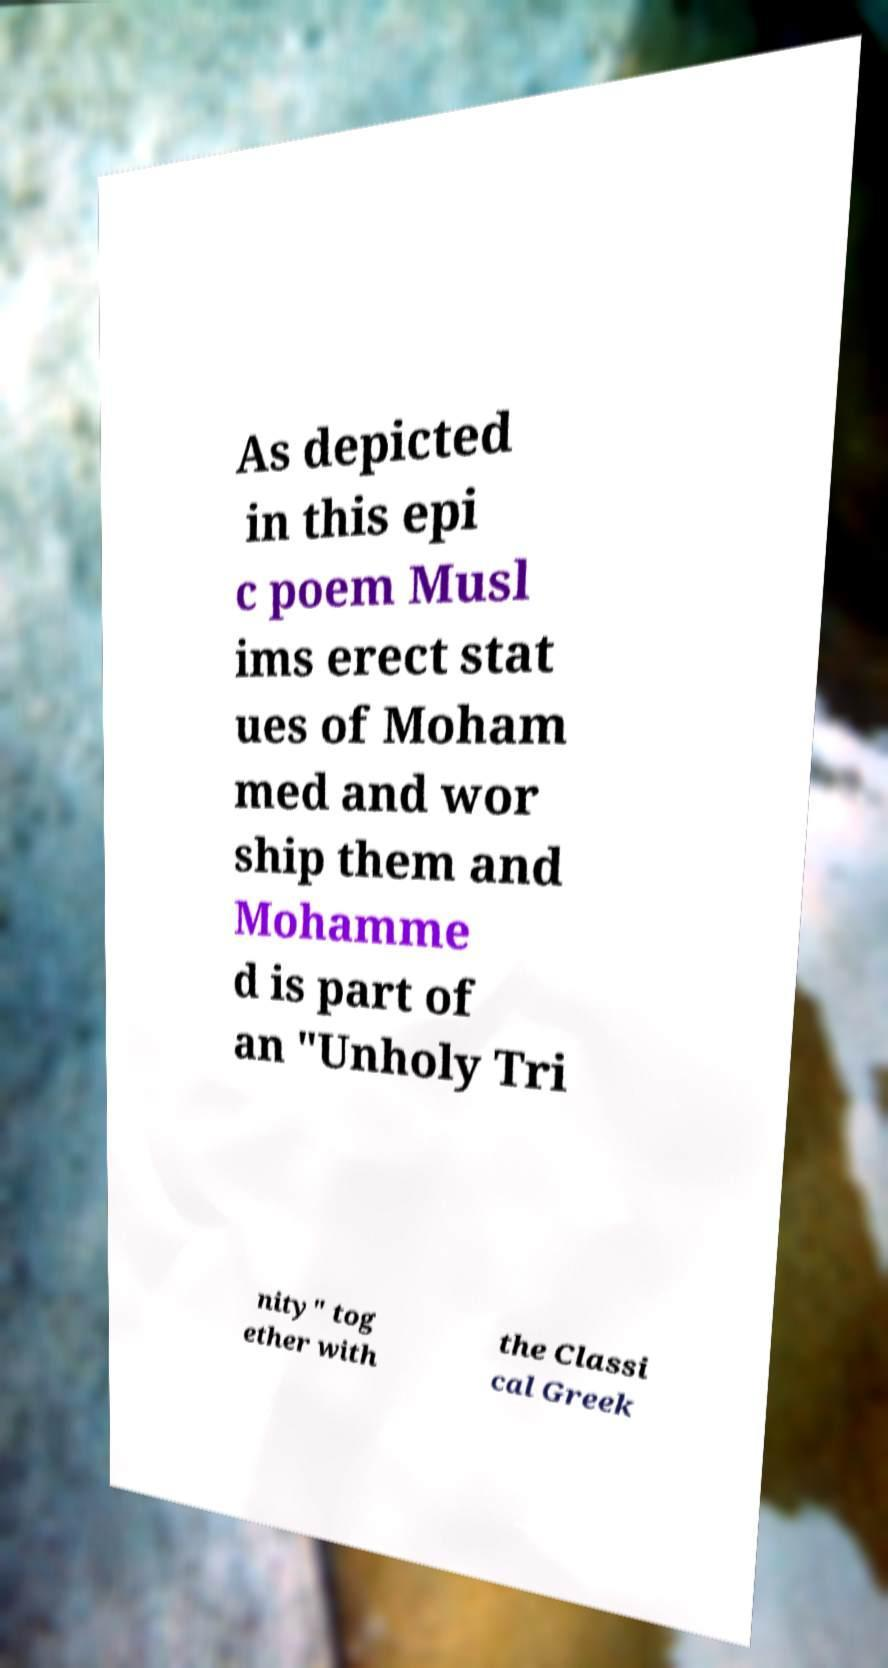Could you assist in decoding the text presented in this image and type it out clearly? As depicted in this epi c poem Musl ims erect stat ues of Moham med and wor ship them and Mohamme d is part of an "Unholy Tri nity" tog ether with the Classi cal Greek 